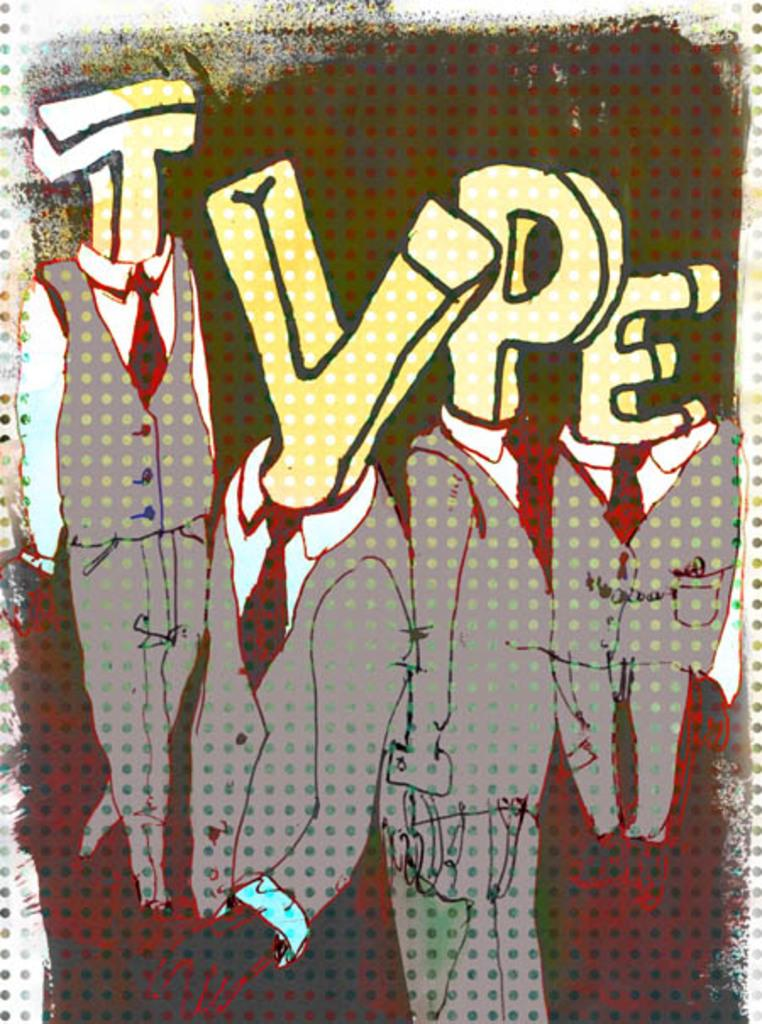What type of image is being described? The image is an animation. Who or what can be seen in the animation? There are people in the animation. Are there any words or letters in the image? Yes, there is text in the image. What type of sweater is the record wearing in the image? There is no record or sweater present in the image, as it is an animation featuring people and text. 